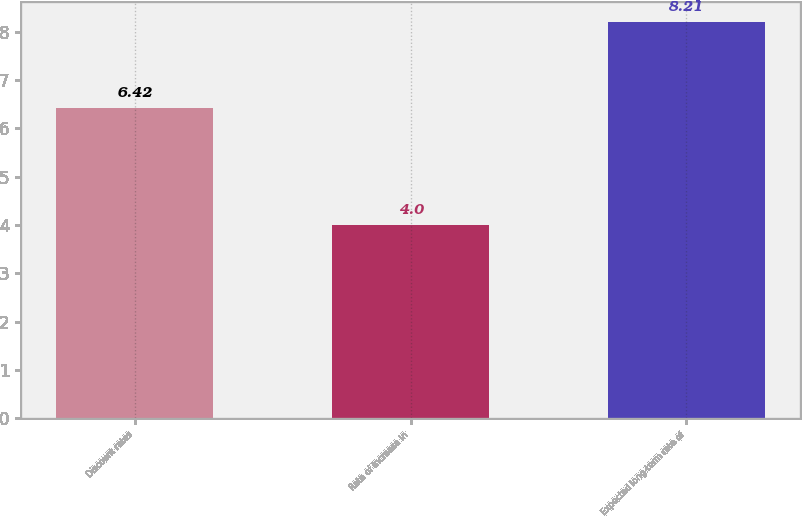<chart> <loc_0><loc_0><loc_500><loc_500><bar_chart><fcel>Discount rates<fcel>Rate of increase in<fcel>Expected long-term rate of<nl><fcel>6.42<fcel>4<fcel>8.21<nl></chart> 